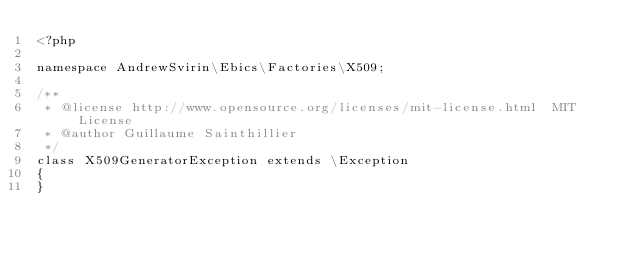Convert code to text. <code><loc_0><loc_0><loc_500><loc_500><_PHP_><?php

namespace AndrewSvirin\Ebics\Factories\X509;

/**
 * @license http://www.opensource.org/licenses/mit-license.html  MIT License
 * @author Guillaume Sainthillier
 */
class X509GeneratorException extends \Exception
{
}
</code> 